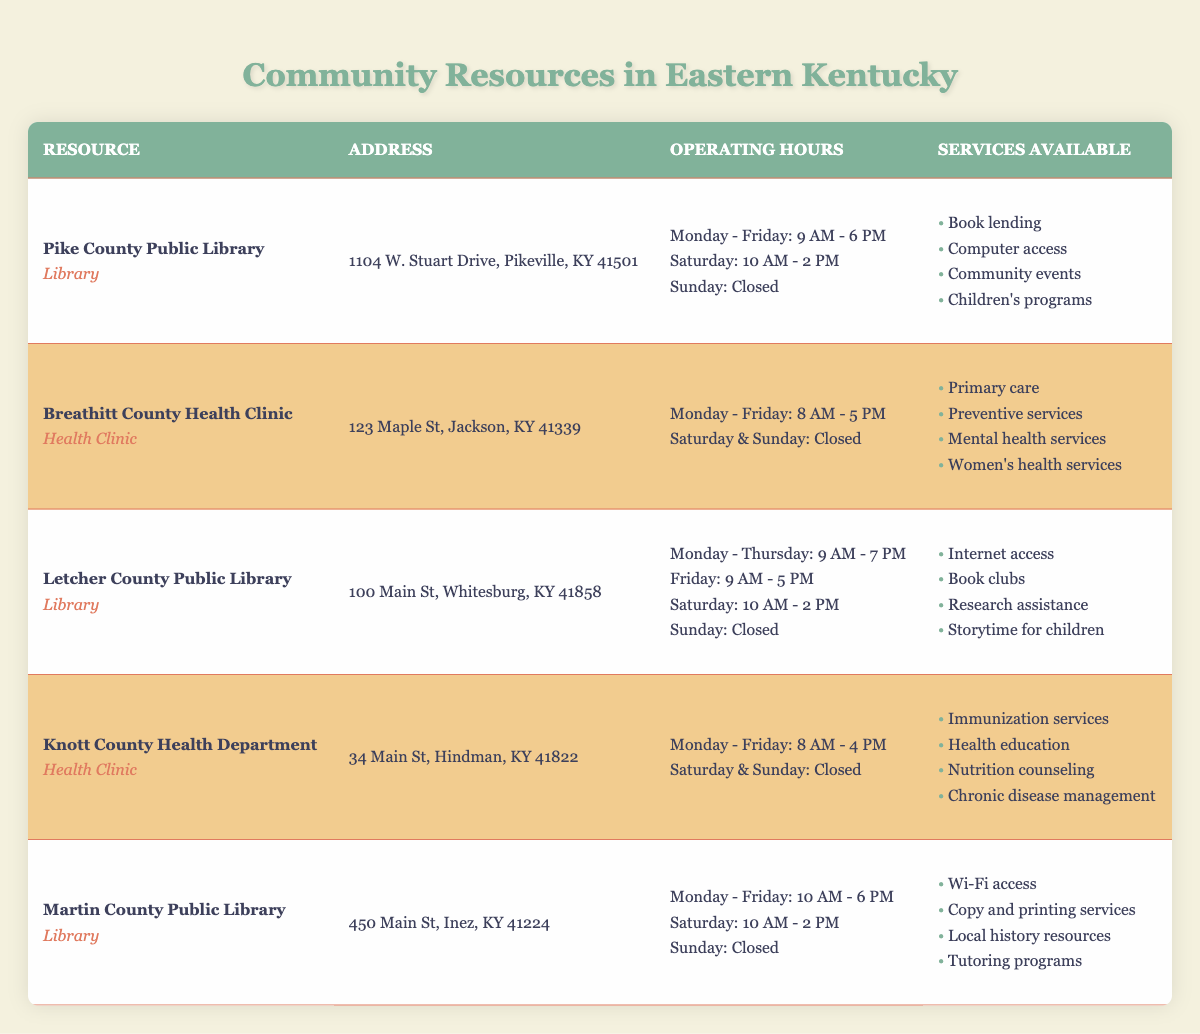What are the operating hours of Pike County Public Library? According to the table, the operating hours for Pike County Public Library are Monday - Friday from 9 AM to 6 PM, Saturday from 10 AM to 2 PM, and it is closed on Sunday.
Answer: Monday - Friday: 9 AM - 6 PM, Saturday: 10 AM - 2 PM, Sunday: Closed How many libraries are listed in the table? The table contains three libraries: Pike County Public Library, Letcher County Public Library, and Martin County Public Library.
Answer: 3 Can you access the Internet at Letcher County Public Library? Yes, the table indicates that Internet access is one of the services available at Letcher County Public Library.
Answer: Yes What services does Martin County Public Library offer? Martin County Public Library offers Wi-Fi access, copy and printing services, local history resources, and tutoring programs, as listed in the table.
Answer: Wi-Fi access, copy and printing services, local history resources, tutoring programs What is the latest closing time of any community resource listed? The latest closing time is 7 PM on weekdays for Letcher County Public Library. To find this, we compare the closing times: Pike County Public Library closes at 6 PM, Breathitt County Health Clinic at 5 PM, Knott County Health Department at 4 PM, and Martin County Public Library at 6 PM. Only Letcher County Public Library closes at 7 PM, making it the latest.
Answer: 7 PM Are there any health clinics that operate on weekends? No, both health clinics listed, Breathitt County Health Clinic and Knott County Health Department, are closed on weekends, as noted in their operating hours in the table.
Answer: No How many health services are provided by the Breathitt County Health Clinic? The Breathitt County Health Clinic provides four specific services: primary care, preventive services, mental health services, and women’s health services. This can be confirmed by counting the items listed under services available in the table.
Answer: 4 Which type of resource offers community events? The Pike County Public Library offers community events as one of its services. This is identified by scanning the services available for each entry in the table.
Answer: Library What is the difference between the operating hours of Letcher County Public Library and Knott County Health Department on weekdays? Letcher County Public Library operates from 9 AM to 7 PM while Knott County Health Department operates from 8 AM to 4 PM. The difference in closing times is 3 hours, with Letcher County closing later than Knott County. This requires calculation by considering the closing hour for each resource.
Answer: 3 hours 